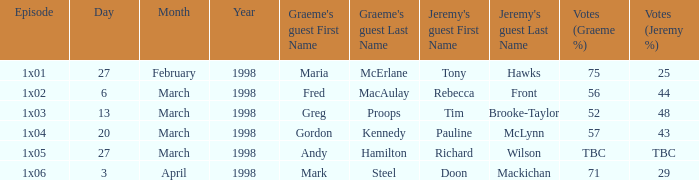What is Episode, when Jeremy's Guest is "Pauline McLynn"? 1x04. 